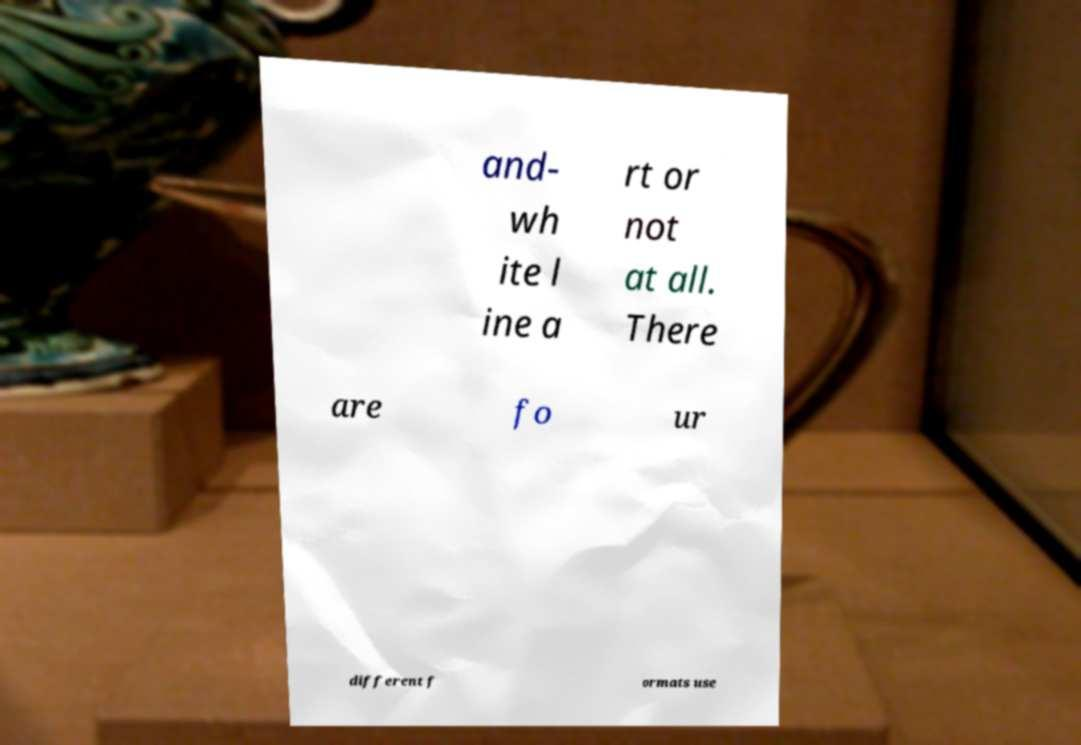Can you accurately transcribe the text from the provided image for me? and- wh ite l ine a rt or not at all. There are fo ur different f ormats use 